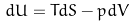<formula> <loc_0><loc_0><loc_500><loc_500>d U = T d S - p d V</formula> 